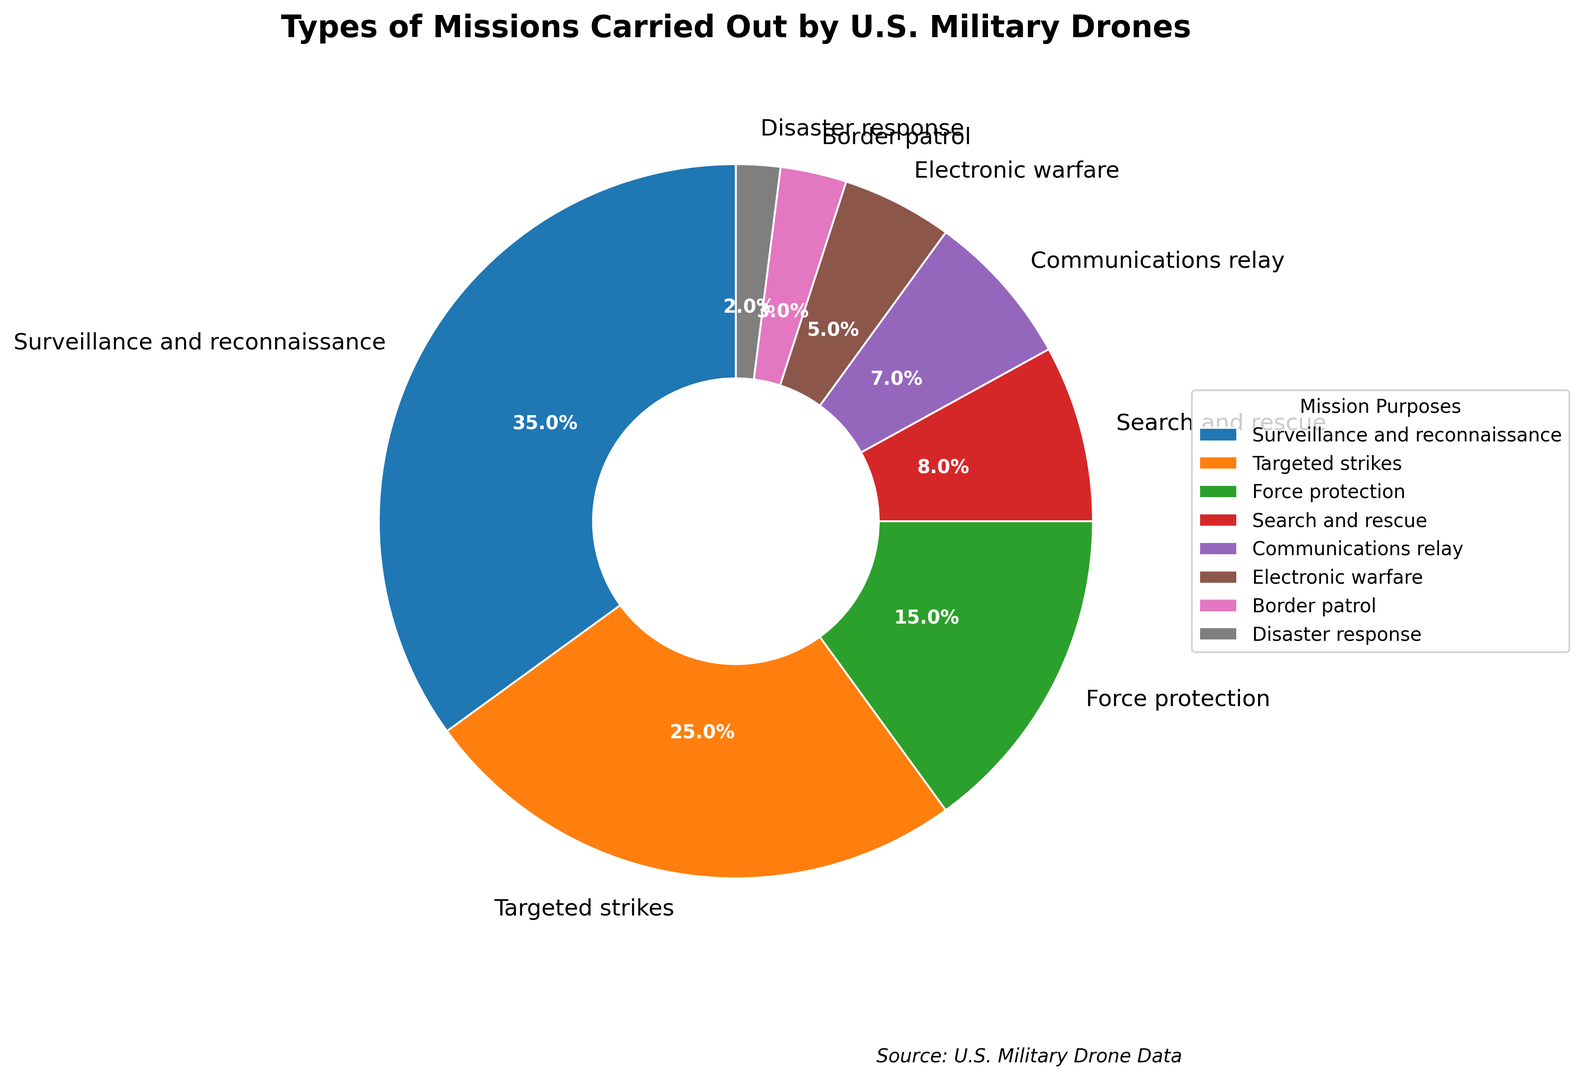Which type of mission carries the highest percentage of operations? Look at the segment with the largest area. The "Surveillance and reconnaissance" segment is the largest and shows 35%.
Answer: Surveillance and reconnaissance Which two types of missions account for more than half of all military drone operations? Sum the percentages of the largest segments until the sum exceeds 50%. The largest segment is "Surveillance and reconnaissance" (35%) and the second largest is "Targeted strikes" (25%). Their sum is 35% + 25% = 60%.
Answer: Surveillance and reconnaissance, and Targeted strikes How does the percentage of "Force protection" compare to the percentage of "Search and rescue"? Both percentages need to be directly compared. "Force protection" is at 15% while "Search and rescue" is at 8%.
Answer: Force protection is greater than Search and rescue What is the combined percentage of the three least common types of missions? Identify the smallest percentages and sum them up. The three smallest are "Border patrol" (3%), "Disaster response" (2%), and "Electronic warfare" (5%). Their sum is 3% + 2% + 5% = 10%.
Answer: 10% What is the difference in percentage points between "Communications relay" and "Search and rescue" missions? Subtract the smaller percentage from the larger percentage. "Communications relay" is 7% and "Search and rescue" is 8%. The difference is 8% - 7% = 1%.
Answer: 1% Which mission type has a slice with a similar size to the "Border patrol" slice? Compare visually similar slices in size to "Border patrol," which is 3%. "Disaster response" is also small, at 2%, making it the closest in size.
Answer: Disaster response If these categories were grouped into "Operational" and "Non-operational" missions, with "Non-operational" including "Search and rescue," "Communications relay," "Border patrol," and "Disaster response," what is the percentage for each group? Sum the "Non-operational" mission percentages: 8% (Search and rescue) + 7% (Communications relay) + 3% (Border patrol) + 2% (Disaster response) = 20%. The "Operational" missions would be the total (100%) minus "Non-operational" (20%), giving 80%.
Answer: Operational: 80%, Non-operational: 20% How much more prevalent are "Surveillance and reconnaissance" missions compared to "Electronic warfare" missions? Deduct the percentage of "Electronic warfare" (5%) from "Surveillance and reconnaissance" (35%). The difference is 35% - 5% = 30%.
Answer: 30% How many mission types collectively constitute less than 50% of all drone operations? Add smallest segments until reaching 50%. Starting from the smallest: 2% (Disaster response) + 3% (Border patrol) + 5% (Electronic warfare) + 7% (Communications relay) + 8% (Search and rescue) + 15% (Force protection) = 40%. Adding the next segment, "Targeted strikes" (25%), exceeds 50%. So, the count is 6 types.
Answer: 6 